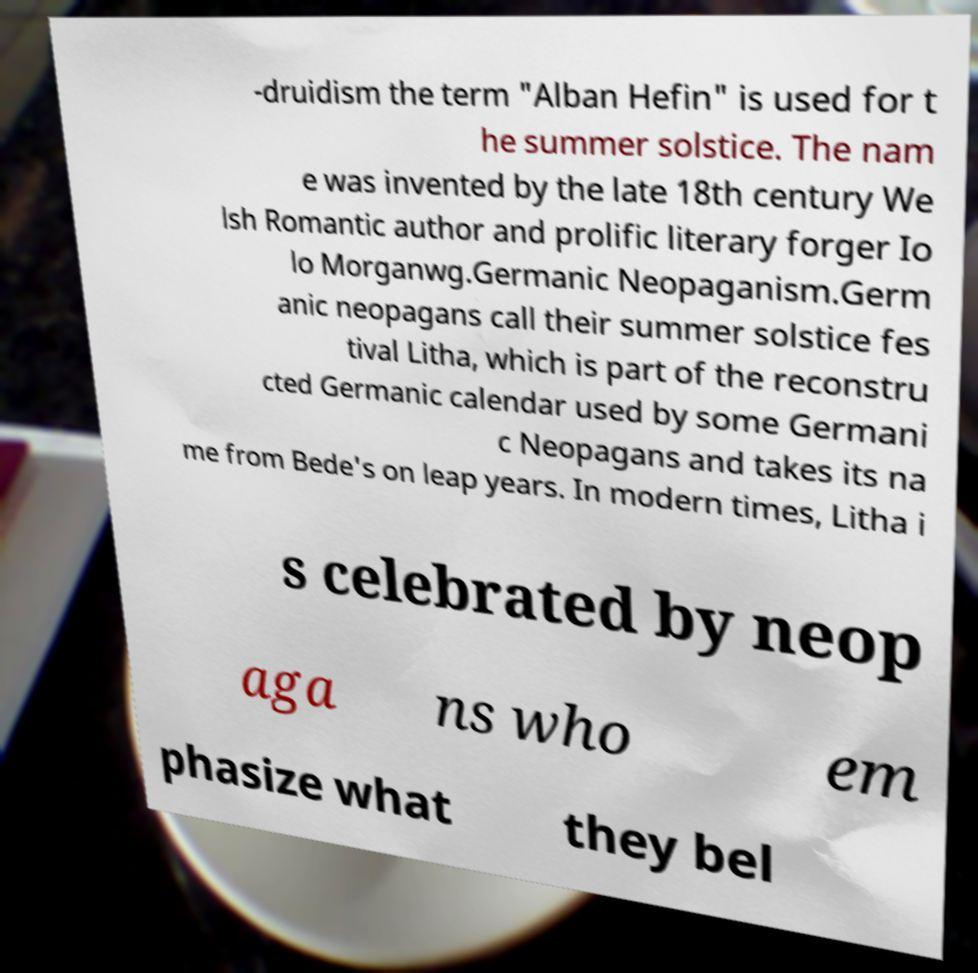Please identify and transcribe the text found in this image. -druidism the term "Alban Hefin" is used for t he summer solstice. The nam e was invented by the late 18th century We lsh Romantic author and prolific literary forger Io lo Morganwg.Germanic Neopaganism.Germ anic neopagans call their summer solstice fes tival Litha, which is part of the reconstru cted Germanic calendar used by some Germani c Neopagans and takes its na me from Bede's on leap years. In modern times, Litha i s celebrated by neop aga ns who em phasize what they bel 